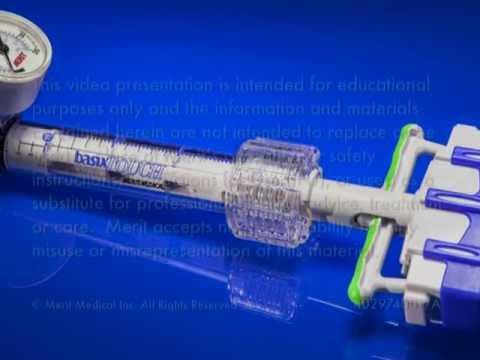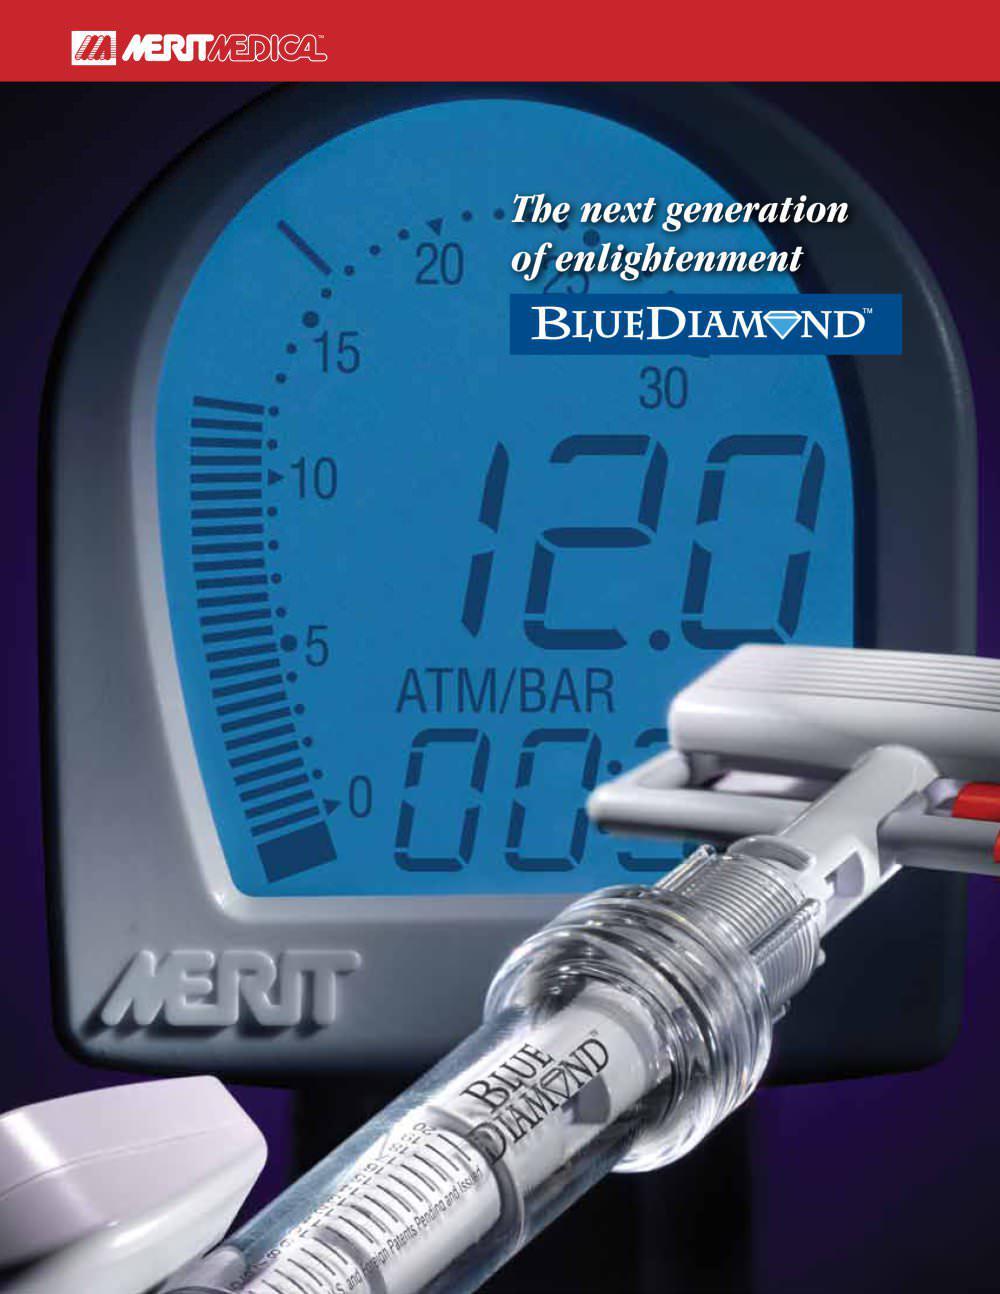The first image is the image on the left, the second image is the image on the right. Analyze the images presented: Is the assertion "At least 1 device has a red stripe above it." valid? Answer yes or no. Yes. 